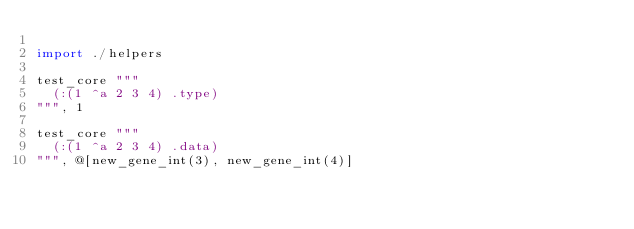<code> <loc_0><loc_0><loc_500><loc_500><_Nim_>
import ./helpers

test_core """
  (:(1 ^a 2 3 4) .type)
""", 1

test_core """
  (:(1 ^a 2 3 4) .data)
""", @[new_gene_int(3), new_gene_int(4)]
</code> 